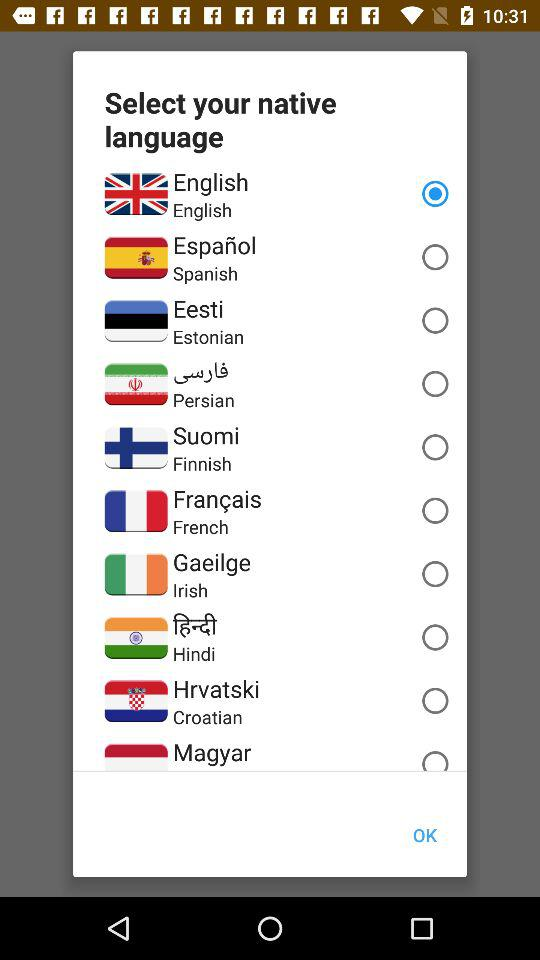How many languages are available to choose from?
Answer the question using a single word or phrase. 10 